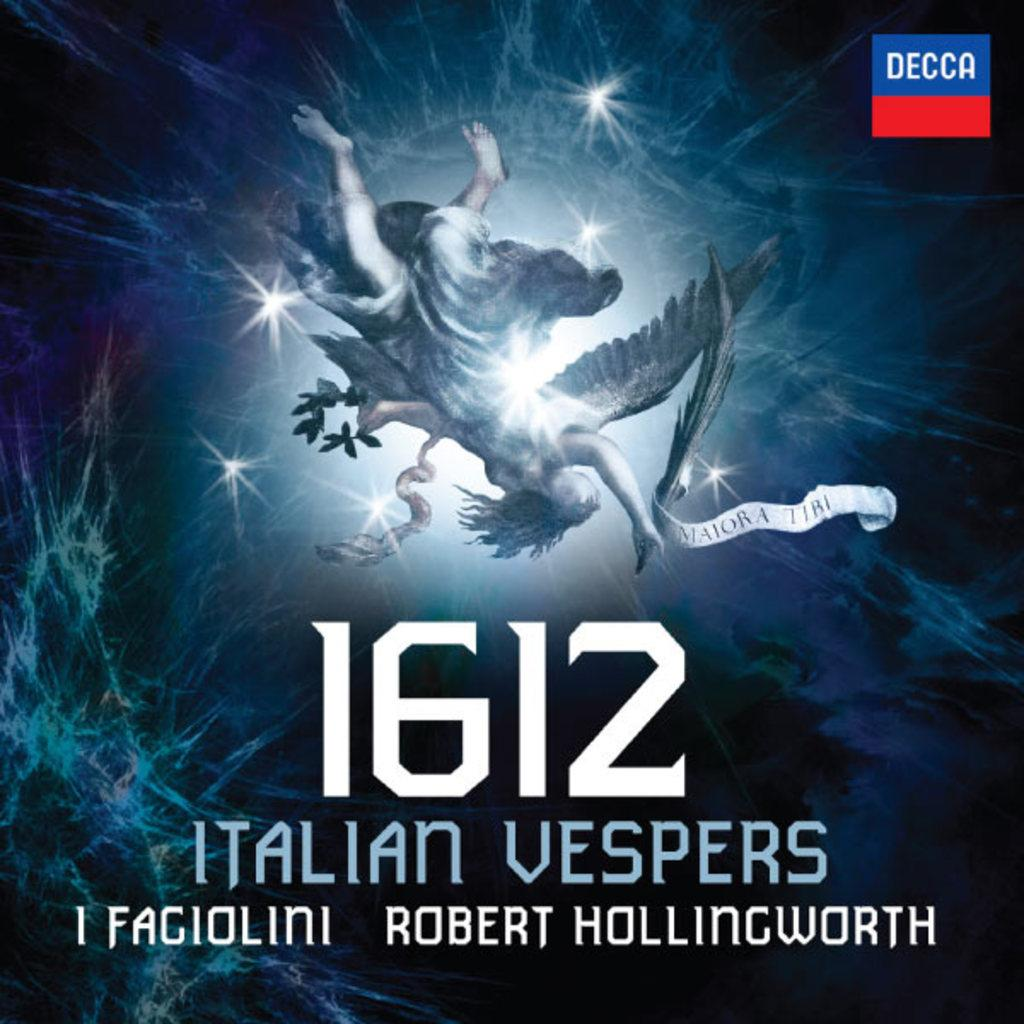<image>
Give a short and clear explanation of the subsequent image. 1612 Italian vespers 1 fagiolini by Robert Hollingworth 